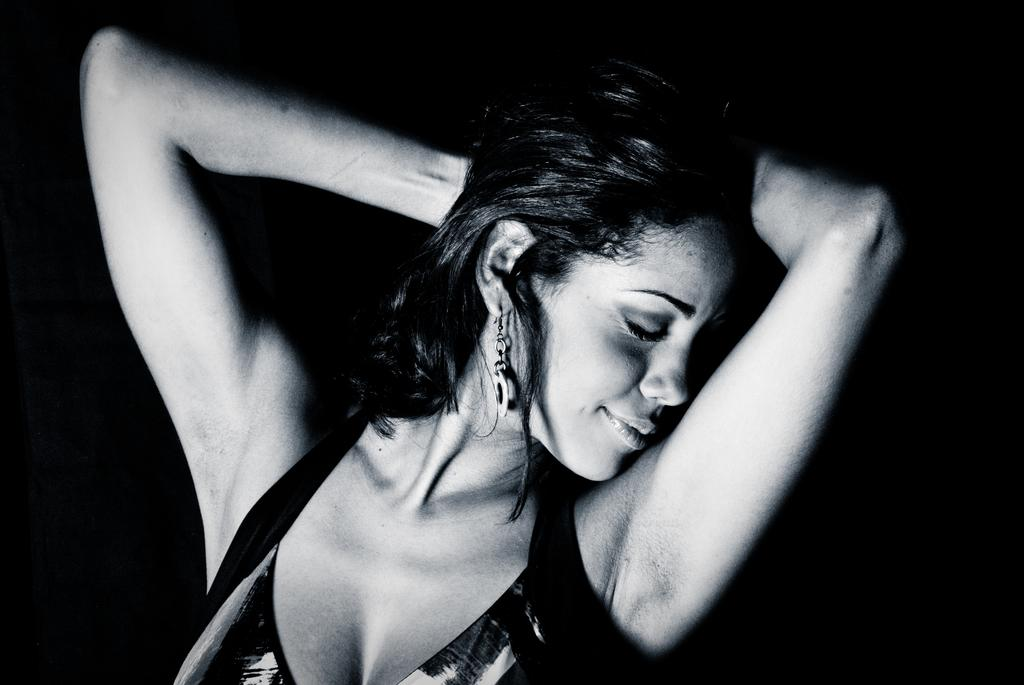Who is the main subject in the image? There is a lady in the image. What is the lady wearing? The lady is wearing a black dress. Can you describe the lady's face in the image? The lady's face is visible in the image. What type of eggs can be seen in the image? There are no eggs present in the image; it features a lady wearing a black dress. Can you describe the conversation the lady is having with the bee in the image? There is no bee present in the image, and the lady is not engaged in any conversation. 